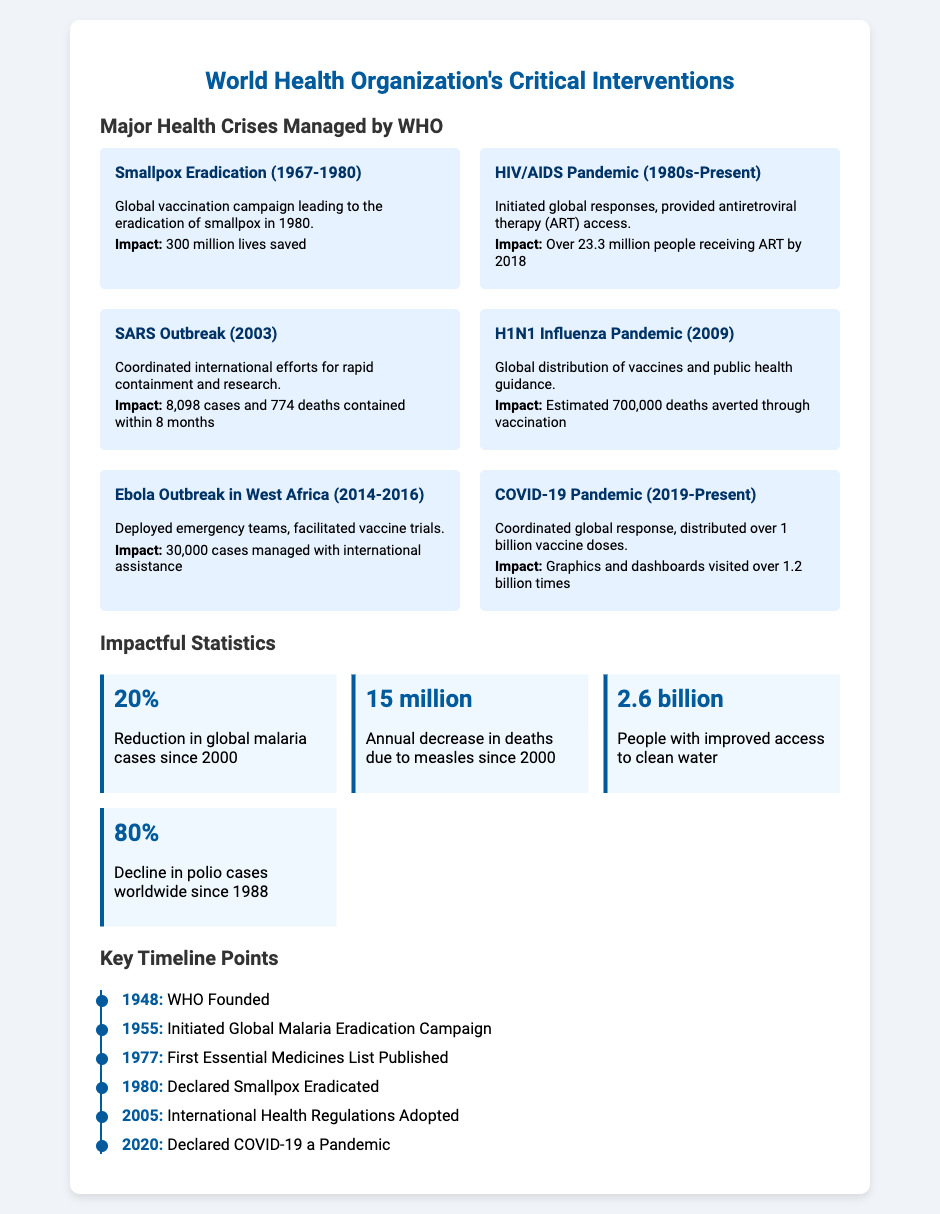What year was smallpox declared eradicated? The document specifies that smallpox was declared eradicated in the year 1980.
Answer: 1980 How many people were receiving ART by 2018? The document states that over 23.3 million people were receiving antiretroviral therapy by 2018.
Answer: 23.3 million What was the impact of the Ebola outbreak management? According to the document, 30,000 cases were managed with international assistance during the Ebola outbreak in West Africa.
Answer: 30,000 cases What percentage of decline in polio cases has occurred since 1988? The document notes that there has been an 80% decline in polio cases worldwide since 1988.
Answer: 80% What significant health event did the WHO declare in 2020? The document indicates that the WHO declared COVID-19 a pandemic in 2020.
Answer: COVID-19 a pandemic Which hurricane coordinated efforts in 2003? The document specifies that SARS outbreak measures were coordinated in 2003.
Answer: SARS When was the WHO founded? The document indicates that the World Health Organization was founded in 1948.
Answer: 1948 How many vaccine doses were distributed during the COVID-19 pandemic? The document states that over 1 billion vaccine doses were distributed during the COVID-19 pandemic.
Answer: Over 1 billion 